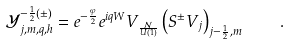<formula> <loc_0><loc_0><loc_500><loc_500>\mathcal { Y } _ { j , m , q , h } ^ { - \frac { 1 } { 2 } ( \pm ) } = e ^ { - \frac { \varphi } { 2 } } e ^ { i q W } V _ { \frac { \mathcal { N } } { U ( 1 ) } } \left ( S ^ { \pm } V _ { j } \right ) _ { j - \frac { 1 } { 2 } , m } \quad .</formula> 